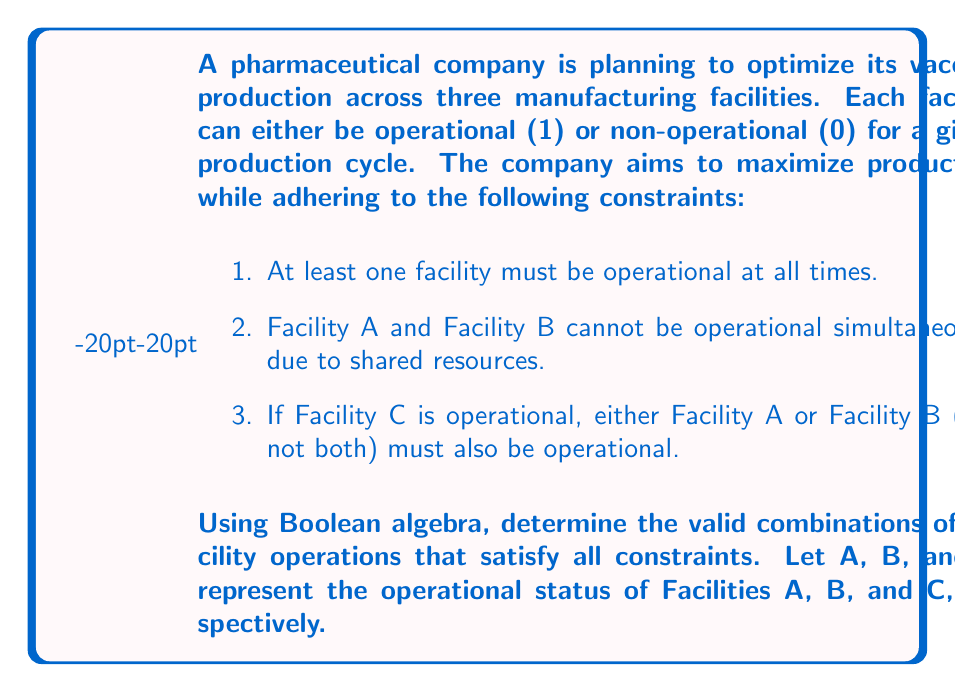Solve this math problem. Let's approach this step-by-step using Boolean algebra:

1) First, let's express each constraint as a Boolean expression:

   Constraint 1: $A + B + C \geq 1$, which is equivalent to $A + B + C = 1$
   Constraint 2: $\overline{(A \cdot B)}$, which is equivalent to $A \cdot B = 0$
   Constraint 3: $C \rightarrow (A \oplus B)$, where $\oplus$ is XOR

2) We can combine these constraints into a single Boolean expression:

   $F(A,B,C) = (A + B + C) \cdot \overline{(A \cdot B)} \cdot (C \rightarrow (A \oplus B))$

3) Let's expand the implication in Constraint 3:
   $C \rightarrow (A \oplus B)$ is equivalent to $\overline{C} + (A \oplus B)$

4) Now our function becomes:
   $F(A,B,C) = (A + B + C) \cdot \overline{(A \cdot B)} \cdot (\overline{C} + (A \oplus B))$

5) We can evaluate this function for all possible combinations of A, B, and C:

   $F(0,0,0) = 0 \cdot 1 \cdot 1 = 0$
   $F(0,0,1) = 1 \cdot 1 \cdot 0 = 0$
   $F(0,1,0) = 1 \cdot 1 \cdot 1 = 1$
   $F(0,1,1) = 1 \cdot 1 \cdot 1 = 1$
   $F(1,0,0) = 1 \cdot 1 \cdot 1 = 1$
   $F(1,0,1) = 1 \cdot 1 \cdot 1 = 1$
   $F(1,1,0) = 1 \cdot 0 \cdot 1 = 0$
   $F(1,1,1) = 1 \cdot 0 \cdot 1 = 0$

6) The valid combinations are those where $F(A,B,C) = 1$:
   (0,1,0), (0,1,1), (1,0,0), (1,0,1)

These combinations represent the valid operational states for the facilities that satisfy all constraints.
Answer: (0,1,0), (0,1,1), (1,0,0), (1,0,1) 